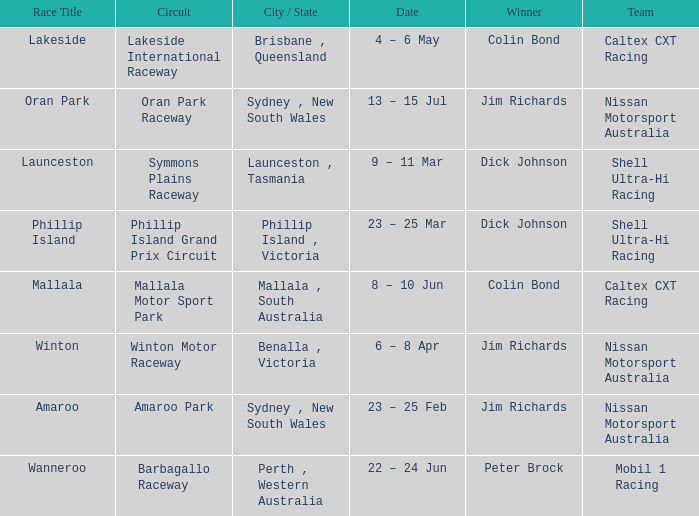Could you parse the entire table as a dict? {'header': ['Race Title', 'Circuit', 'City / State', 'Date', 'Winner', 'Team'], 'rows': [['Lakeside', 'Lakeside International Raceway', 'Brisbane , Queensland', '4 – 6 May', 'Colin Bond', 'Caltex CXT Racing'], ['Oran Park', 'Oran Park Raceway', 'Sydney , New South Wales', '13 – 15 Jul', 'Jim Richards', 'Nissan Motorsport Australia'], ['Launceston', 'Symmons Plains Raceway', 'Launceston , Tasmania', '9 – 11 Mar', 'Dick Johnson', 'Shell Ultra-Hi Racing'], ['Phillip Island', 'Phillip Island Grand Prix Circuit', 'Phillip Island , Victoria', '23 – 25 Mar', 'Dick Johnson', 'Shell Ultra-Hi Racing'], ['Mallala', 'Mallala Motor Sport Park', 'Mallala , South Australia', '8 – 10 Jun', 'Colin Bond', 'Caltex CXT Racing'], ['Winton', 'Winton Motor Raceway', 'Benalla , Victoria', '6 – 8 Apr', 'Jim Richards', 'Nissan Motorsport Australia'], ['Amaroo', 'Amaroo Park', 'Sydney , New South Wales', '23 – 25 Feb', 'Jim Richards', 'Nissan Motorsport Australia'], ['Wanneroo', 'Barbagallo Raceway', 'Perth , Western Australia', '22 – 24 Jun', 'Peter Brock', 'Mobil 1 Racing']]} When is the lakeside race scheduled for? 4 – 6 May. 